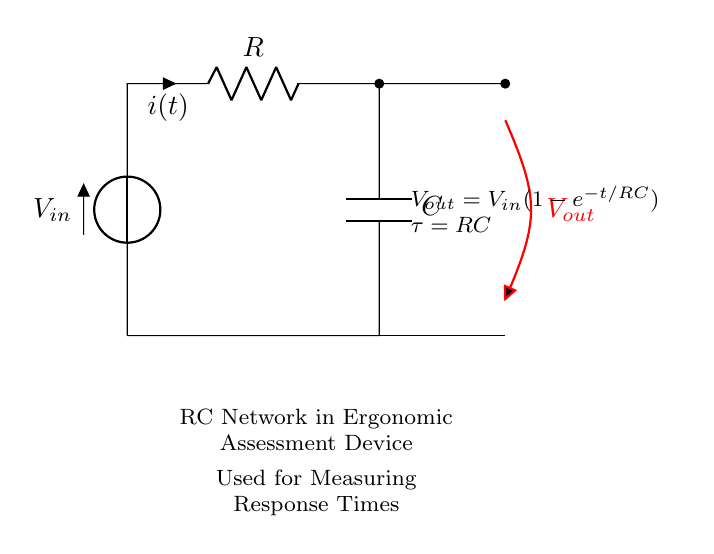What is the input voltage in the circuit? The input voltage is labeled as \( V_{in} \), which is the source voltage supplied to the circuit.
Answer: \( V_{in} \) What component is connected across \( V_{out} \)? The component connected across \( V_{out} \) is the capacitor \( C \), responsible for storing charge and affecting the output voltage over time.
Answer: \( C \) What does the equation \( V_{out} = V_{in}(1-e^{-t/RC}) \) represent? This equation describes the output voltage over time in an RC circuit, showing how the voltage rises as the capacitor charges.
Answer: Charging curve What is the time constant \( \tau \) in this circuit? The time constant \( \tau \) is given by the product of resistance \( R \) and capacitance \( C \), defining how quickly the capacitor charges and discharges.
Answer: \( RC \) What happens to \( V_{out} \) as \( t \) approaches infinity? As time approaches infinity, the output voltage \( V_{out} \) approaches \( V_{in} \), which indicates that the capacitor becomes fully charged and no longer allows current to flow.
Answer: \( V_{in} \) Which component controls the current in the circuit? The resistor \( R \) controls the current flowing through the circuit, limiting the rate at which the capacitor charges.
Answer: \( R \) How does the capacitance affect the charging time? Increasing the capacitance \( C \) results in a longer charging time, as the time constant \( \tau = RC \) increases, slowing down the response time of the circuit.
Answer: Longer charging time 